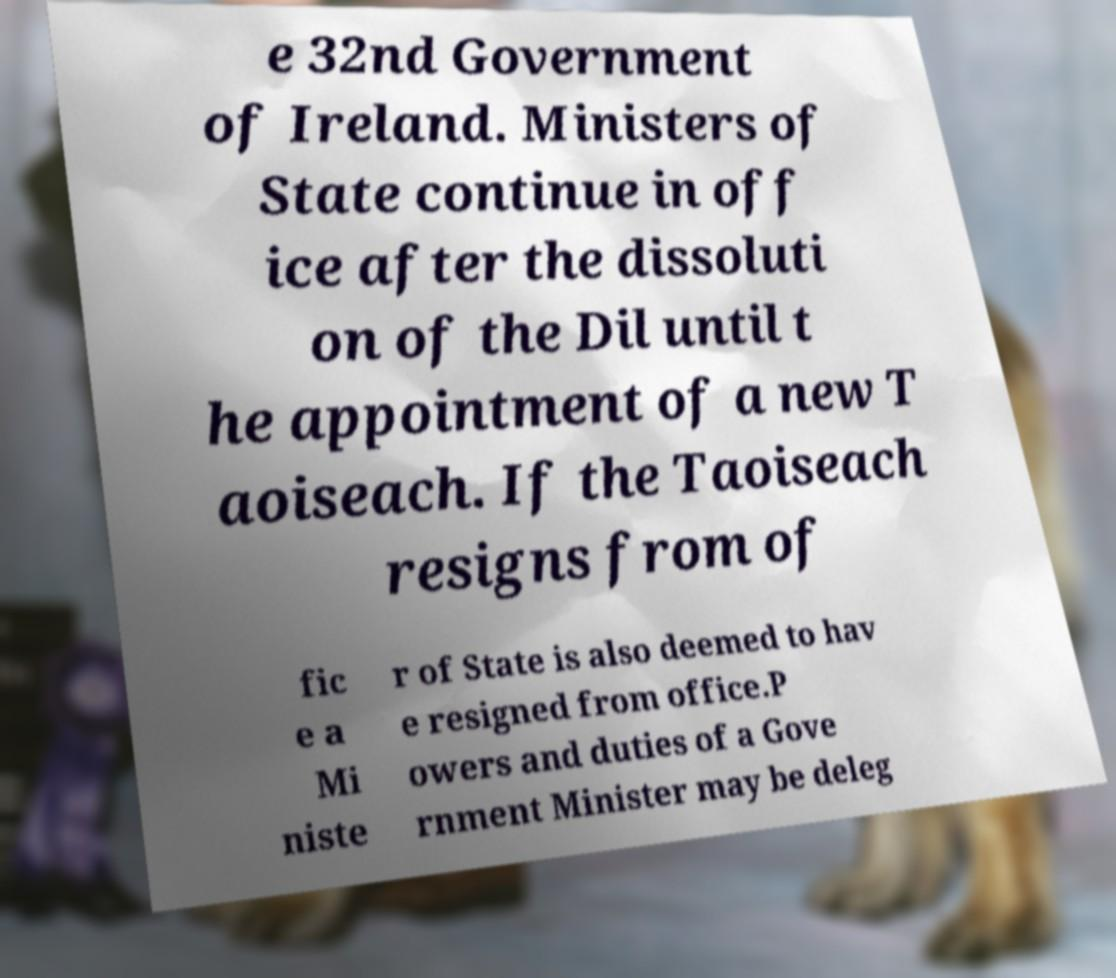There's text embedded in this image that I need extracted. Can you transcribe it verbatim? e 32nd Government of Ireland. Ministers of State continue in off ice after the dissoluti on of the Dil until t he appointment of a new T aoiseach. If the Taoiseach resigns from of fic e a Mi niste r of State is also deemed to hav e resigned from office.P owers and duties of a Gove rnment Minister may be deleg 